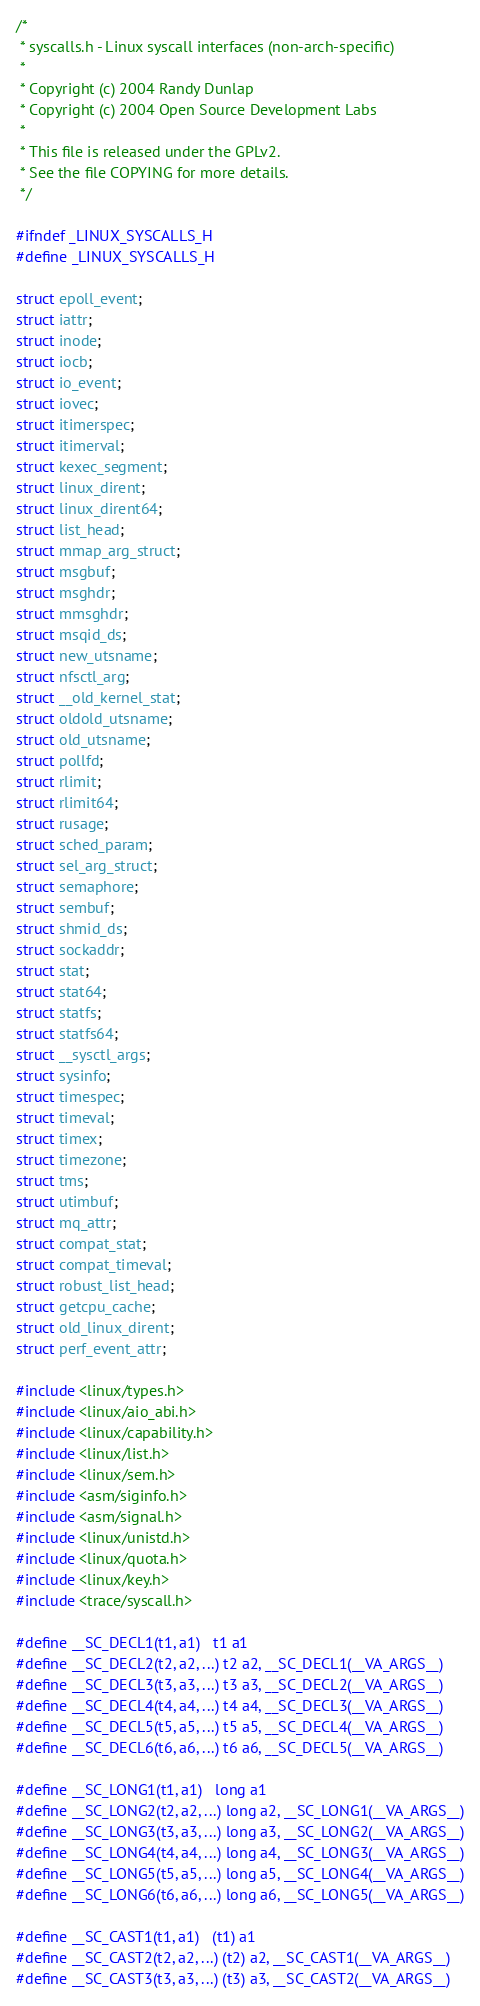<code> <loc_0><loc_0><loc_500><loc_500><_C_>/*
 * syscalls.h - Linux syscall interfaces (non-arch-specific)
 *
 * Copyright (c) 2004 Randy Dunlap
 * Copyright (c) 2004 Open Source Development Labs
 *
 * This file is released under the GPLv2.
 * See the file COPYING for more details.
 */

#ifndef _LINUX_SYSCALLS_H
#define _LINUX_SYSCALLS_H

struct epoll_event;
struct iattr;
struct inode;
struct iocb;
struct io_event;
struct iovec;
struct itimerspec;
struct itimerval;
struct kexec_segment;
struct linux_dirent;
struct linux_dirent64;
struct list_head;
struct mmap_arg_struct;
struct msgbuf;
struct msghdr;
struct mmsghdr;
struct msqid_ds;
struct new_utsname;
struct nfsctl_arg;
struct __old_kernel_stat;
struct oldold_utsname;
struct old_utsname;
struct pollfd;
struct rlimit;
struct rlimit64;
struct rusage;
struct sched_param;
struct sel_arg_struct;
struct semaphore;
struct sembuf;
struct shmid_ds;
struct sockaddr;
struct stat;
struct stat64;
struct statfs;
struct statfs64;
struct __sysctl_args;
struct sysinfo;
struct timespec;
struct timeval;
struct timex;
struct timezone;
struct tms;
struct utimbuf;
struct mq_attr;
struct compat_stat;
struct compat_timeval;
struct robust_list_head;
struct getcpu_cache;
struct old_linux_dirent;
struct perf_event_attr;

#include <linux/types.h>
#include <linux/aio_abi.h>
#include <linux/capability.h>
#include <linux/list.h>
#include <linux/sem.h>
#include <asm/siginfo.h>
#include <asm/signal.h>
#include <linux/unistd.h>
#include <linux/quota.h>
#include <linux/key.h>
#include <trace/syscall.h>

#define __SC_DECL1(t1, a1)	t1 a1
#define __SC_DECL2(t2, a2, ...) t2 a2, __SC_DECL1(__VA_ARGS__)
#define __SC_DECL3(t3, a3, ...) t3 a3, __SC_DECL2(__VA_ARGS__)
#define __SC_DECL4(t4, a4, ...) t4 a4, __SC_DECL3(__VA_ARGS__)
#define __SC_DECL5(t5, a5, ...) t5 a5, __SC_DECL4(__VA_ARGS__)
#define __SC_DECL6(t6, a6, ...) t6 a6, __SC_DECL5(__VA_ARGS__)

#define __SC_LONG1(t1, a1) 	long a1
#define __SC_LONG2(t2, a2, ...) long a2, __SC_LONG1(__VA_ARGS__)
#define __SC_LONG3(t3, a3, ...) long a3, __SC_LONG2(__VA_ARGS__)
#define __SC_LONG4(t4, a4, ...) long a4, __SC_LONG3(__VA_ARGS__)
#define __SC_LONG5(t5, a5, ...) long a5, __SC_LONG4(__VA_ARGS__)
#define __SC_LONG6(t6, a6, ...) long a6, __SC_LONG5(__VA_ARGS__)

#define __SC_CAST1(t1, a1)	(t1) a1
#define __SC_CAST2(t2, a2, ...) (t2) a2, __SC_CAST1(__VA_ARGS__)
#define __SC_CAST3(t3, a3, ...) (t3) a3, __SC_CAST2(__VA_ARGS__)</code> 